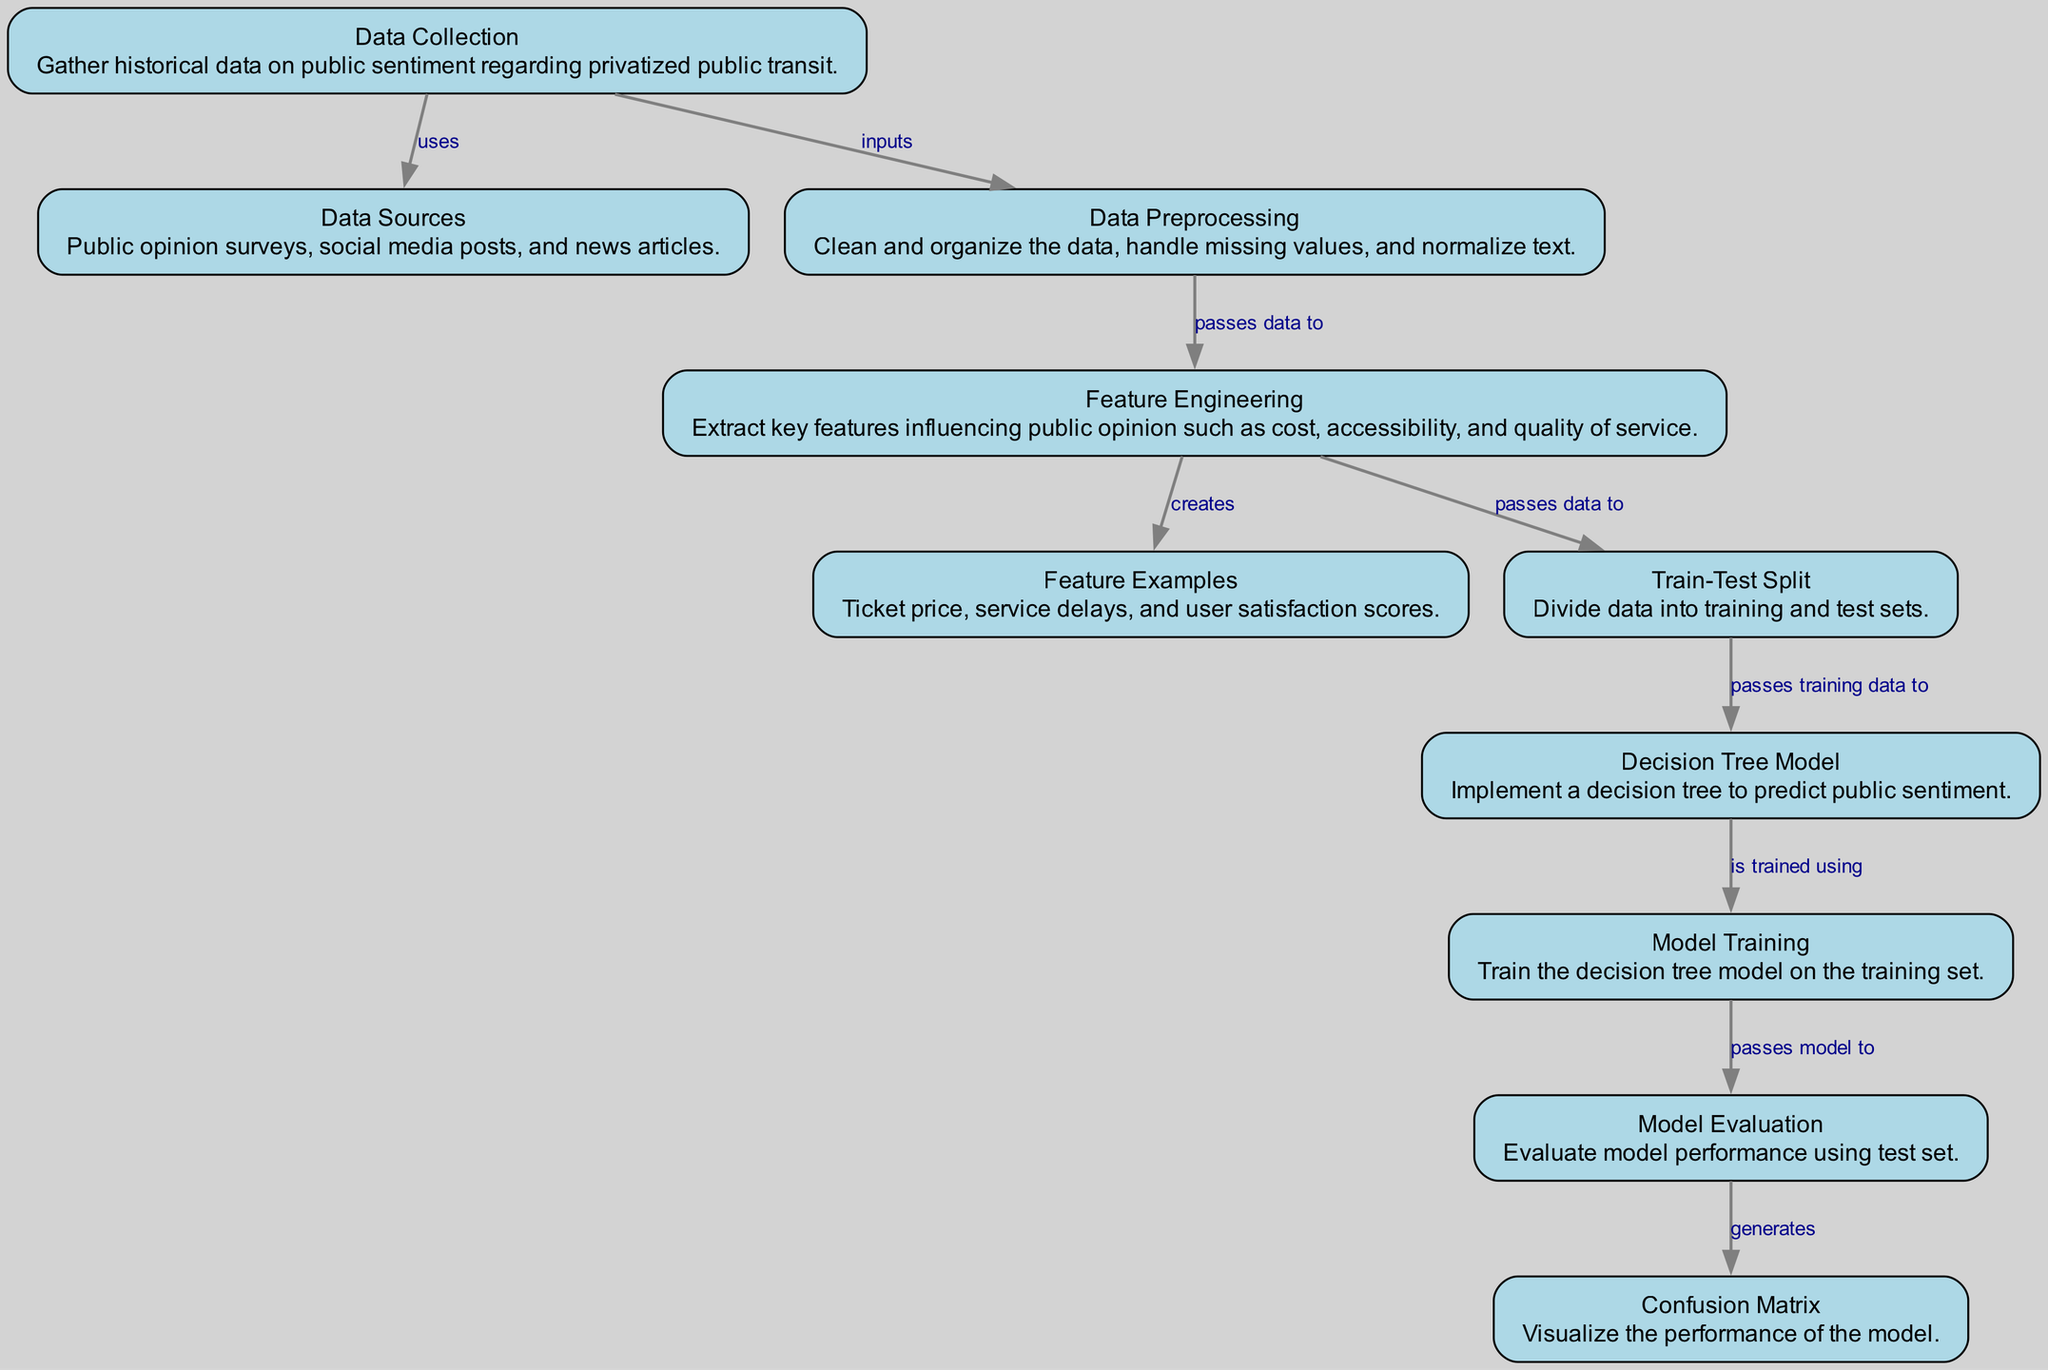what is the first step in the diagram? The diagram starts with the "Data Collection" node, which indicates that the first step involves gathering historical data on public sentiment regarding privatized public transit.
Answer: Data Collection how many nodes are in the diagram? By counting the nodes listed in the diagram, there are a total of ten distinct nodes shown.
Answer: Ten which node generates the confusion matrix? The "Model Evaluation" node generates the confusion matrix as indicated by the edge labeled "generates" pointing towards the "Confusion Matrix" node.
Answer: Model Evaluation what data sources are used in the data collection? The "Data Sources" node mentions that public opinion surveys, social media posts, and news articles are used as sources for data collection.
Answer: Public opinion surveys, social media posts, news articles what is passed to the decision tree model? The "Train-Test Split" node passes the training data to the "Decision Tree Model," indicating that this is the data the model uses to learn.
Answer: Training data why do we preprocess the data before feature engineering? Data preprocessing is essential to clean and organize the data, handling missing values and normalizing text so that accurate and meaningful features can be extracted later in the feature engineering step.
Answer: To clean and organize the data how is the decision tree model trained? The "Model Training" node connects the "Decision Tree Model" and indicates that the model is trained using the training set data prepared from the train-test split.
Answer: By training on the training set which component creates feature examples? The "Feature Engineering" node is responsible for creating feature examples, as it directly generates them based on the extracted key features influencing public opinion.
Answer: Feature Engineering what relationship exists between feature engineering and train-test split? The feature engineering node passes data to the train-test split node, indicating that the features extracted are used to separate the dataset into training and testing sets for further analysis.
Answer: Passes data to 